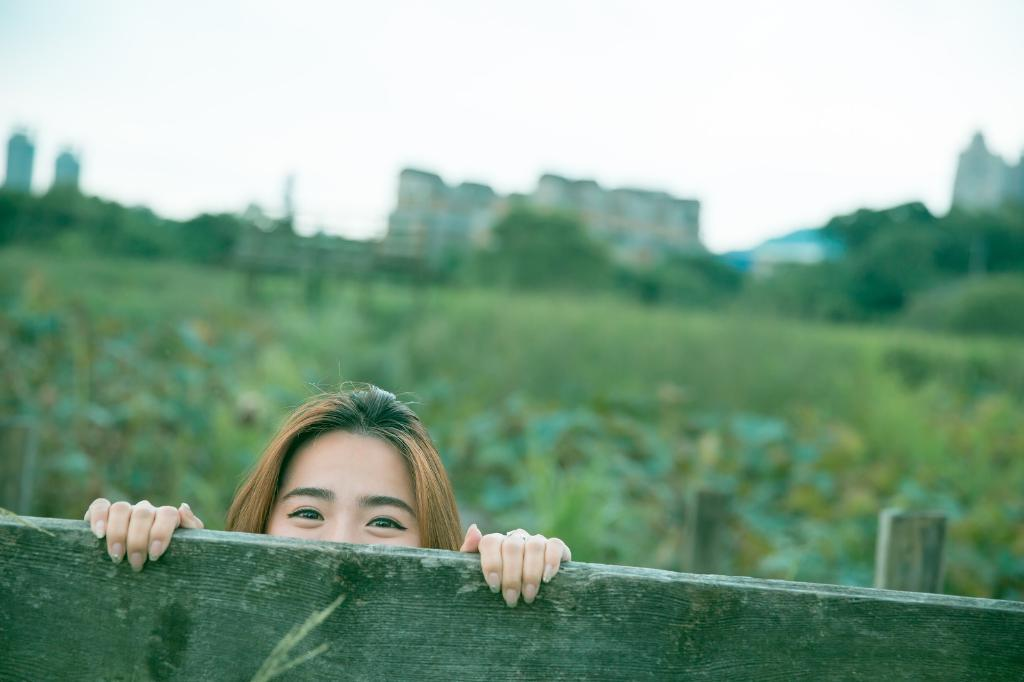What object is located in the foreground of the image? There is a wooden block in the foreground of the image. Can you describe the woman's expression in the image? The woman appears to be smiling in the image. What can be seen in the background of the image? There are buildings and trees in the background of the image. How many needles are being used by the woman in the image? There are no needles present in the image. What type of rice is being cooked by the woman in the image? There is no rice being cooked in the image; the woman is hiding and smiling. 